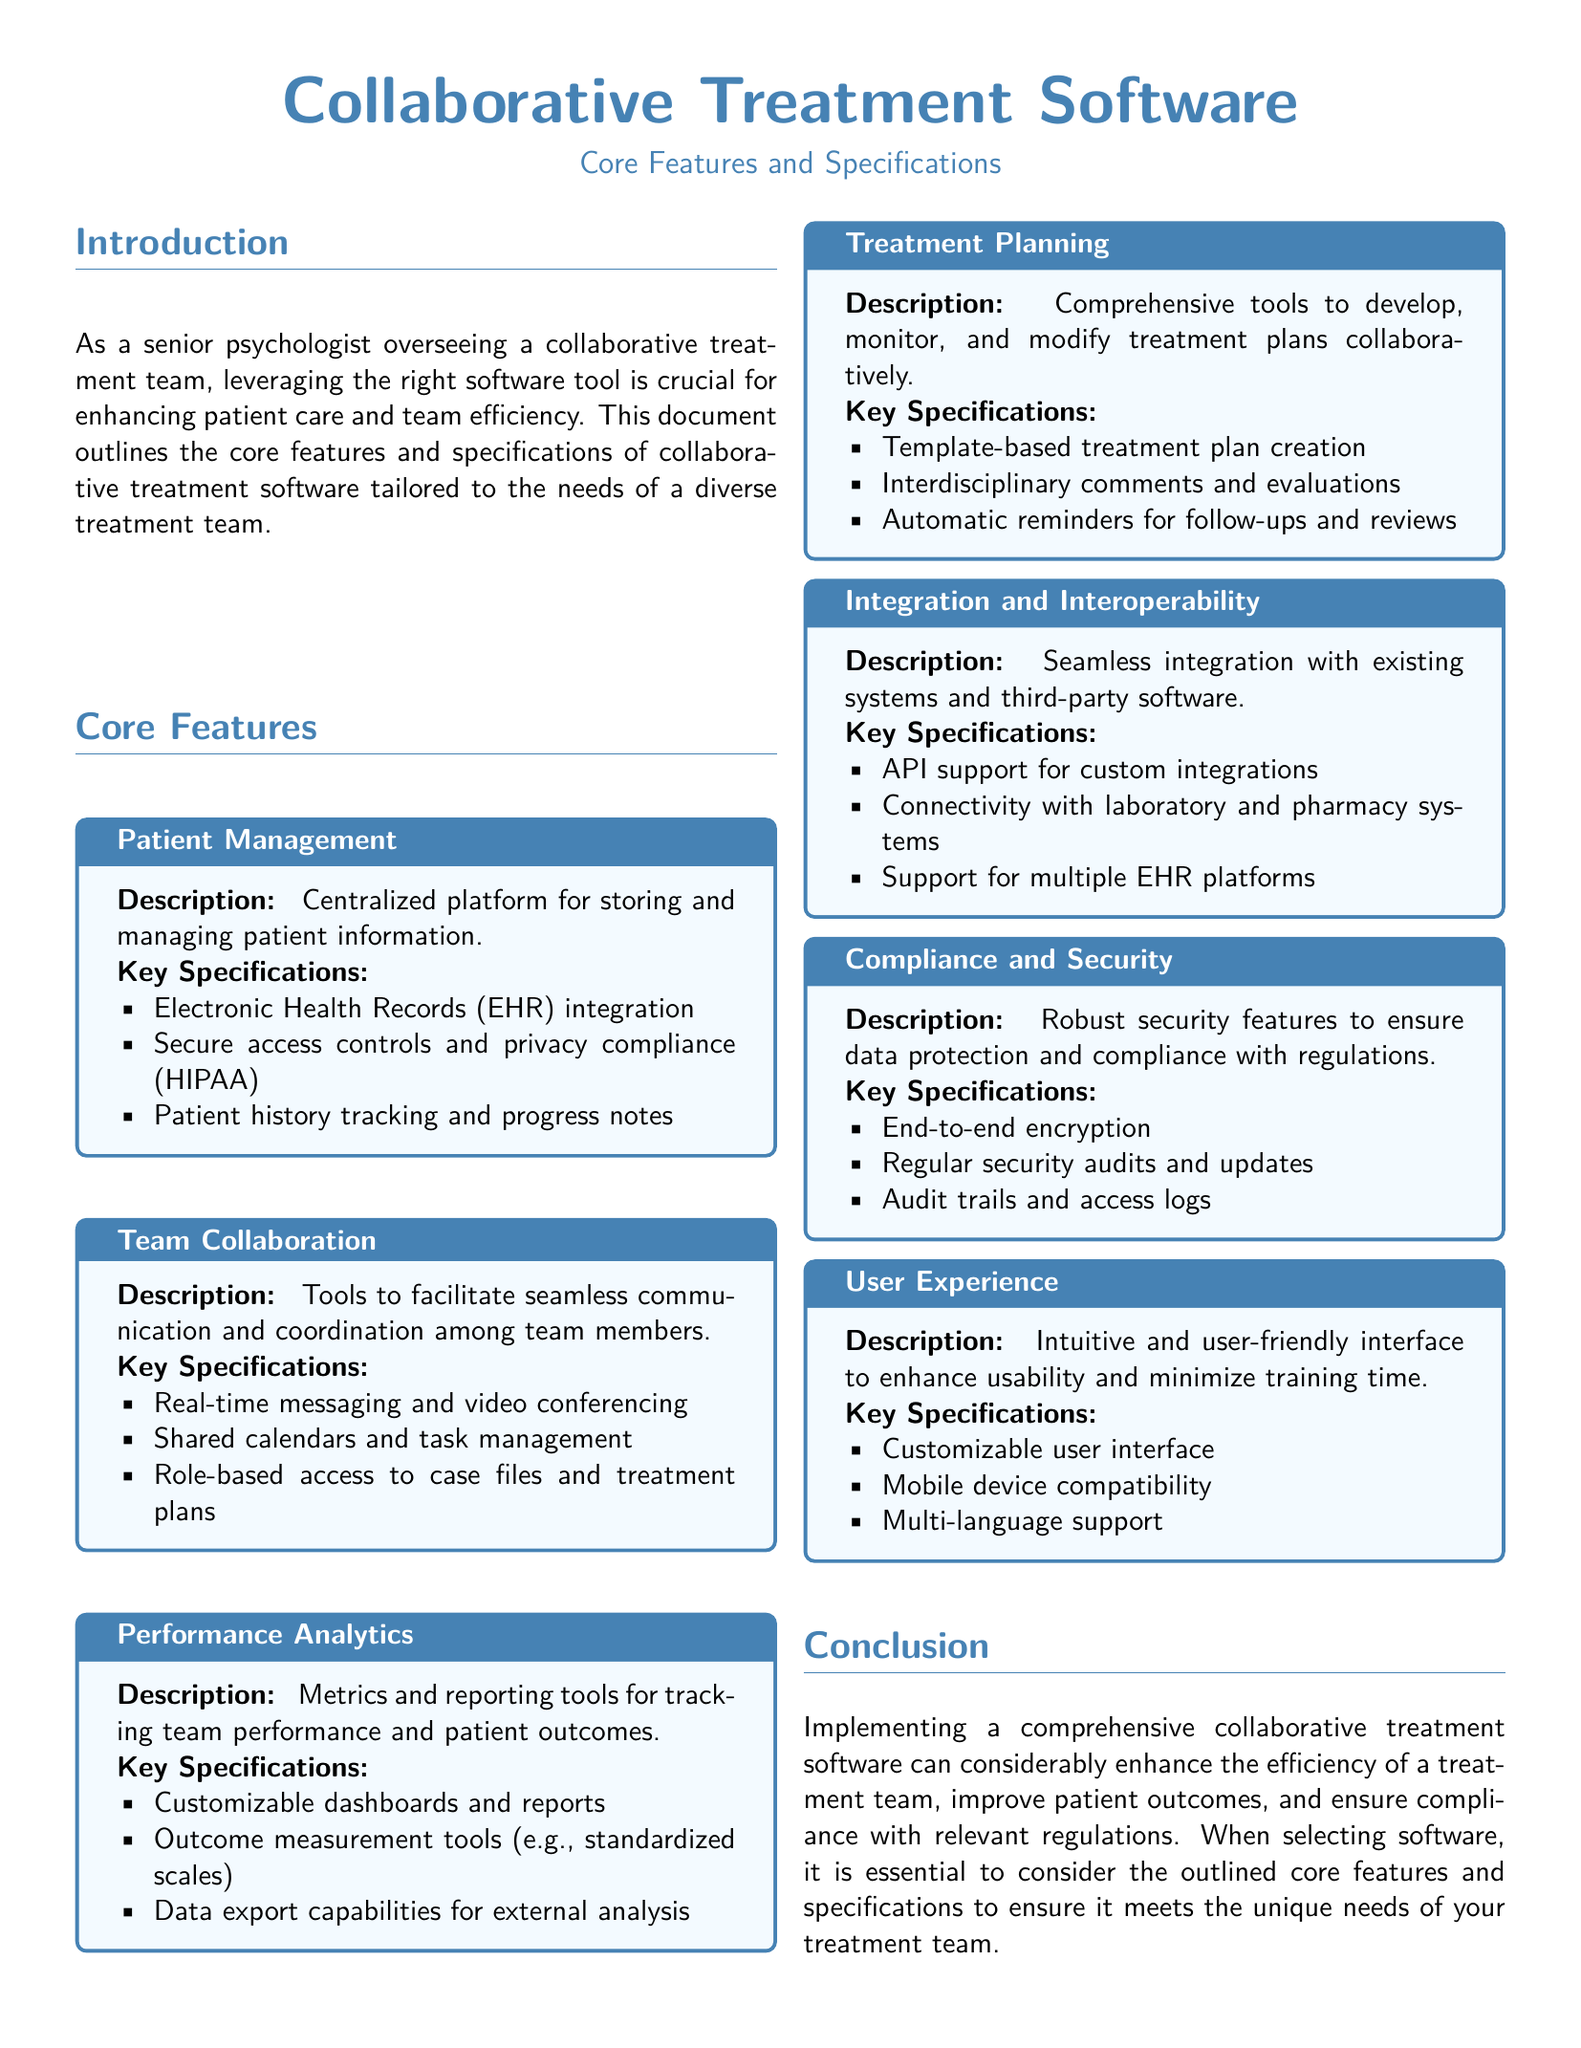what is the main purpose of the document? The document outlines the core features and specifications of collaborative treatment software tailored to the needs of a diverse treatment team.
Answer: outline core features and specifications how many core features are listed in the document? The document details seven core features of the software.
Answer: seven what does the "Patient Management" feature include? The "Patient Management" feature includes Electronic Health Records integration, secure access controls, and patient history tracking.
Answer: EHR integration, secure access controls, patient history tracking which feature focuses on team communication? The feature that focuses on team communication is "Team Collaboration."
Answer: Team Collaboration what is one of the key specifications of the "Performance Analytics" feature? One of the key specifications of the "Performance Analytics" feature is customizable dashboards and reports.
Answer: customizable dashboards and reports does the document mention compliance with HIPAA? Yes, the document states that secure access controls and privacy compliance (HIPAA) are part of the "Patient Management" feature.
Answer: Yes what is a benefit of implementing the software according to the conclusion? Implementing the software can enhance the efficiency of a treatment team.
Answer: enhance team efficiency what kind of compatibility does the "User Experience" feature support? The "User Experience" feature supports mobile device compatibility.
Answer: mobile device compatibility 